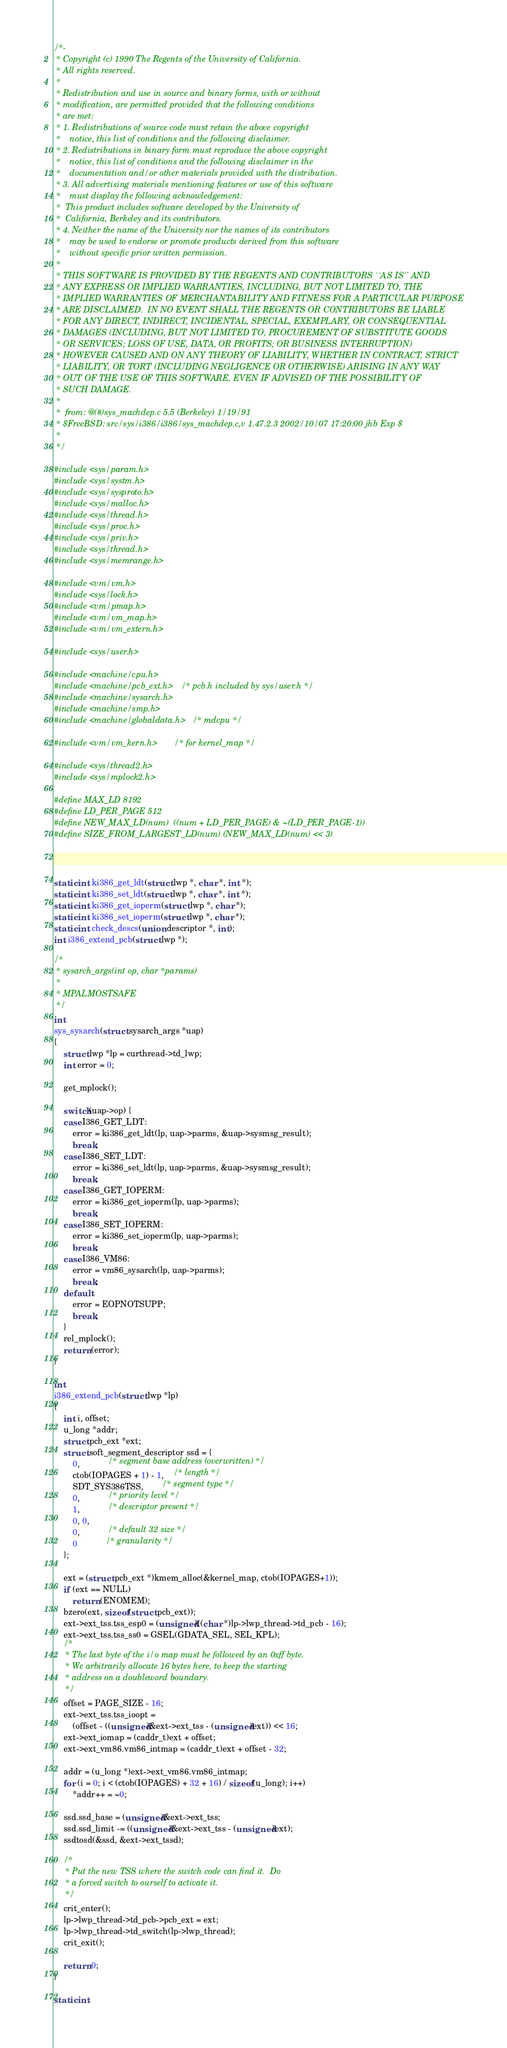<code> <loc_0><loc_0><loc_500><loc_500><_C_>/*-
 * Copyright (c) 1990 The Regents of the University of California.
 * All rights reserved.
 *
 * Redistribution and use in source and binary forms, with or without
 * modification, are permitted provided that the following conditions
 * are met:
 * 1. Redistributions of source code must retain the above copyright
 *    notice, this list of conditions and the following disclaimer.
 * 2. Redistributions in binary form must reproduce the above copyright
 *    notice, this list of conditions and the following disclaimer in the
 *    documentation and/or other materials provided with the distribution.
 * 3. All advertising materials mentioning features or use of this software
 *    must display the following acknowledgement:
 *	This product includes software developed by the University of
 *	California, Berkeley and its contributors.
 * 4. Neither the name of the University nor the names of its contributors
 *    may be used to endorse or promote products derived from this software
 *    without specific prior written permission.
 *
 * THIS SOFTWARE IS PROVIDED BY THE REGENTS AND CONTRIBUTORS ``AS IS'' AND
 * ANY EXPRESS OR IMPLIED WARRANTIES, INCLUDING, BUT NOT LIMITED TO, THE
 * IMPLIED WARRANTIES OF MERCHANTABILITY AND FITNESS FOR A PARTICULAR PURPOSE
 * ARE DISCLAIMED.  IN NO EVENT SHALL THE REGENTS OR CONTRIBUTORS BE LIABLE
 * FOR ANY DIRECT, INDIRECT, INCIDENTAL, SPECIAL, EXEMPLARY, OR CONSEQUENTIAL
 * DAMAGES (INCLUDING, BUT NOT LIMITED TO, PROCUREMENT OF SUBSTITUTE GOODS
 * OR SERVICES; LOSS OF USE, DATA, OR PROFITS; OR BUSINESS INTERRUPTION)
 * HOWEVER CAUSED AND ON ANY THEORY OF LIABILITY, WHETHER IN CONTRACT, STRICT
 * LIABILITY, OR TORT (INCLUDING NEGLIGENCE OR OTHERWISE) ARISING IN ANY WAY
 * OUT OF THE USE OF THIS SOFTWARE, EVEN IF ADVISED OF THE POSSIBILITY OF
 * SUCH DAMAGE.
 *
 *	from: @(#)sys_machdep.c	5.5 (Berkeley) 1/19/91
 * $FreeBSD: src/sys/i386/i386/sys_machdep.c,v 1.47.2.3 2002/10/07 17:20:00 jhb Exp $
 *
 */

#include <sys/param.h>
#include <sys/systm.h>
#include <sys/sysproto.h>
#include <sys/malloc.h>
#include <sys/thread.h>
#include <sys/proc.h>
#include <sys/priv.h>
#include <sys/thread.h>
#include <sys/memrange.h>

#include <vm/vm.h>
#include <sys/lock.h>
#include <vm/pmap.h>
#include <vm/vm_map.h>
#include <vm/vm_extern.h>

#include <sys/user.h>

#include <machine/cpu.h>
#include <machine/pcb_ext.h>	/* pcb.h included by sys/user.h */
#include <machine/sysarch.h>
#include <machine/smp.h>
#include <machine/globaldata.h>	/* mdcpu */

#include <vm/vm_kern.h>		/* for kernel_map */

#include <sys/thread2.h>
#include <sys/mplock2.h>

#define MAX_LD 8192
#define LD_PER_PAGE 512
#define NEW_MAX_LD(num)  ((num + LD_PER_PAGE) & ~(LD_PER_PAGE-1))
#define SIZE_FROM_LARGEST_LD(num) (NEW_MAX_LD(num) << 3)



static int ki386_get_ldt(struct lwp *, char *, int *);
static int ki386_set_ldt(struct lwp *, char *, int *);
static int ki386_get_ioperm(struct lwp *, char *);
static int ki386_set_ioperm(struct lwp *, char *);
static int check_descs(union descriptor *, int);
int i386_extend_pcb(struct lwp *);

/*
 * sysarch_args(int op, char *params)
 *
 * MPALMOSTSAFE
 */
int
sys_sysarch(struct sysarch_args *uap)
{
	struct lwp *lp = curthread->td_lwp;
	int error = 0;

	get_mplock();

	switch(uap->op) {
	case I386_GET_LDT:
		error = ki386_get_ldt(lp, uap->parms, &uap->sysmsg_result);
		break;
	case I386_SET_LDT:
		error = ki386_set_ldt(lp, uap->parms, &uap->sysmsg_result);
		break;
	case I386_GET_IOPERM:
		error = ki386_get_ioperm(lp, uap->parms);
		break;
	case I386_SET_IOPERM:
		error = ki386_set_ioperm(lp, uap->parms);
		break;
	case I386_VM86:
		error = vm86_sysarch(lp, uap->parms);
		break;
	default:
		error = EOPNOTSUPP;
		break;
	}
	rel_mplock();
	return (error);
}

int
i386_extend_pcb(struct lwp *lp)
{
	int i, offset;
	u_long *addr;
	struct pcb_ext *ext;
	struct soft_segment_descriptor ssd = {
		0,			/* segment base address (overwritten) */
		ctob(IOPAGES + 1) - 1,	/* length */
		SDT_SYS386TSS,		/* segment type */
		0,			/* priority level */
		1,			/* descriptor present */
		0, 0,
		0,			/* default 32 size */
		0			/* granularity */
	};

	ext = (struct pcb_ext *)kmem_alloc(&kernel_map, ctob(IOPAGES+1));
	if (ext == NULL)
		return (ENOMEM);
	bzero(ext, sizeof(struct pcb_ext)); 
	ext->ext_tss.tss_esp0 = (unsigned)((char *)lp->lwp_thread->td_pcb - 16);
	ext->ext_tss.tss_ss0 = GSEL(GDATA_SEL, SEL_KPL);
	/*
	 * The last byte of the i/o map must be followed by an 0xff byte.
	 * We arbitrarily allocate 16 bytes here, to keep the starting
	 * address on a doubleword boundary.
	 */
	offset = PAGE_SIZE - 16;
	ext->ext_tss.tss_ioopt = 
	    (offset - ((unsigned)&ext->ext_tss - (unsigned)ext)) << 16;
	ext->ext_iomap = (caddr_t)ext + offset;
	ext->ext_vm86.vm86_intmap = (caddr_t)ext + offset - 32;

	addr = (u_long *)ext->ext_vm86.vm86_intmap;
	for (i = 0; i < (ctob(IOPAGES) + 32 + 16) / sizeof(u_long); i++)
		*addr++ = ~0;

	ssd.ssd_base = (unsigned)&ext->ext_tss;
	ssd.ssd_limit -= ((unsigned)&ext->ext_tss - (unsigned)ext);
	ssdtosd(&ssd, &ext->ext_tssd);

	/* 
	 * Put the new TSS where the switch code can find it.  Do
	 * a forced switch to ourself to activate it.
	 */
	crit_enter();
	lp->lwp_thread->td_pcb->pcb_ext = ext;
	lp->lwp_thread->td_switch(lp->lwp_thread);
	crit_exit();
	
	return 0;
}

static int</code> 